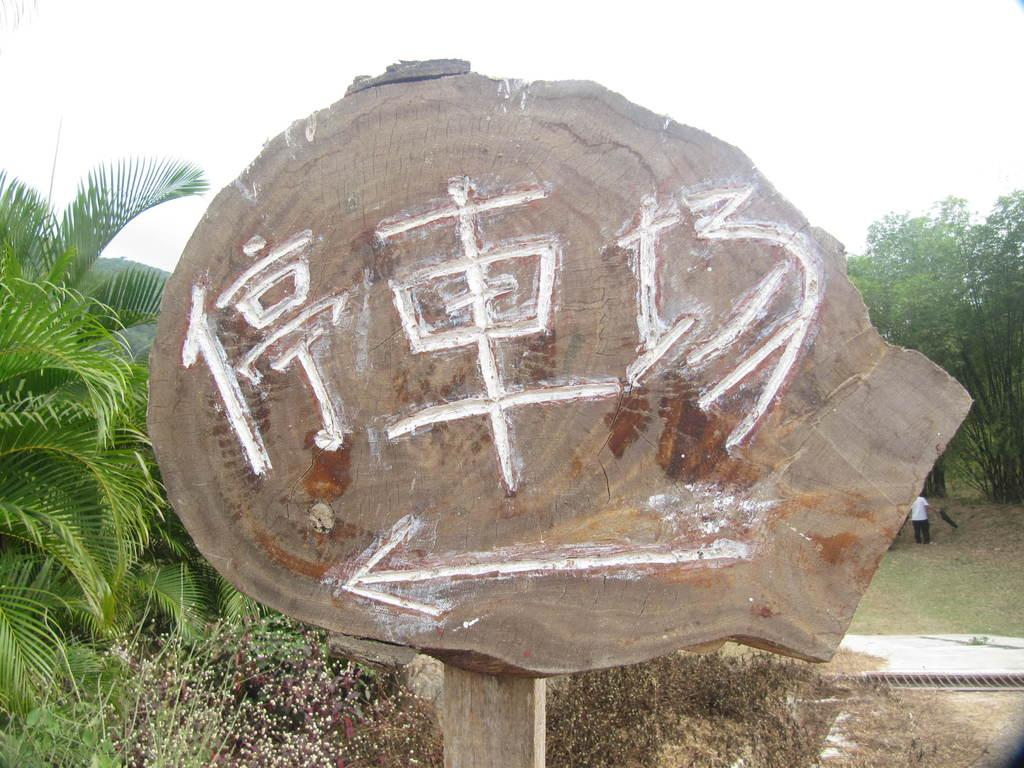What is the main object in the image? There is a wooden board in the image. What is depicted on the wooden board? Something is carved on the wooden board. What can be seen in the background of the image? There are planets, a person wearing a white and black color dress, trees, and the sky visible in the background of the image. How many screws can be seen holding the wooden board together in the image? There are no screws visible in the image; the wooden board is not being held together by screws. Can you tell me how many horses are present in the image? There are no horses present in the image. 